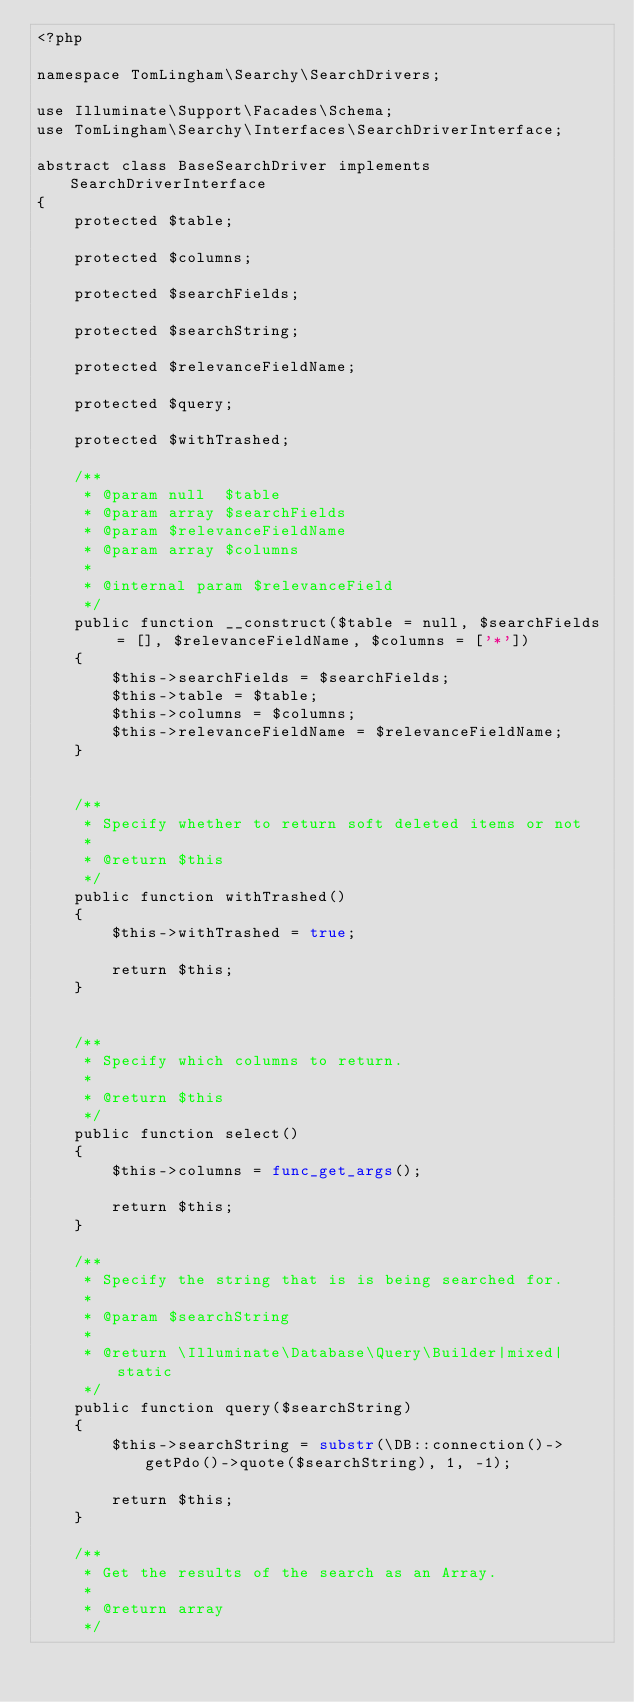Convert code to text. <code><loc_0><loc_0><loc_500><loc_500><_PHP_><?php

namespace TomLingham\Searchy\SearchDrivers;

use Illuminate\Support\Facades\Schema;
use TomLingham\Searchy\Interfaces\SearchDriverInterface;

abstract class BaseSearchDriver implements SearchDriverInterface
{
    protected $table;

    protected $columns;

    protected $searchFields;

    protected $searchString;

    protected $relevanceFieldName;

    protected $query;

    protected $withTrashed;

    /**
     * @param null  $table
     * @param array $searchFields
     * @param $relevanceFieldName
     * @param array $columns
     *
     * @internal param $relevanceField
     */
    public function __construct($table = null, $searchFields = [], $relevanceFieldName, $columns = ['*'])
    {
        $this->searchFields = $searchFields;
        $this->table = $table;
        $this->columns = $columns;
        $this->relevanceFieldName = $relevanceFieldName;
    }


    /**
     * Specify whether to return soft deleted items or not
     *
     * @return $this
     */
    public function withTrashed()
    {
        $this->withTrashed = true;

        return $this;
    }


    /**
     * Specify which columns to return.
     *
     * @return $this
     */
    public function select()
    {
        $this->columns = func_get_args();

        return $this;
    }

    /**
     * Specify the string that is is being searched for.
     *
     * @param $searchString
     *
     * @return \Illuminate\Database\Query\Builder|mixed|static
     */
    public function query($searchString)
    {
        $this->searchString = substr(\DB::connection()->getPdo()->quote($searchString), 1, -1);

        return $this;
    }

    /**
     * Get the results of the search as an Array.
     *
     * @return array
     */</code> 